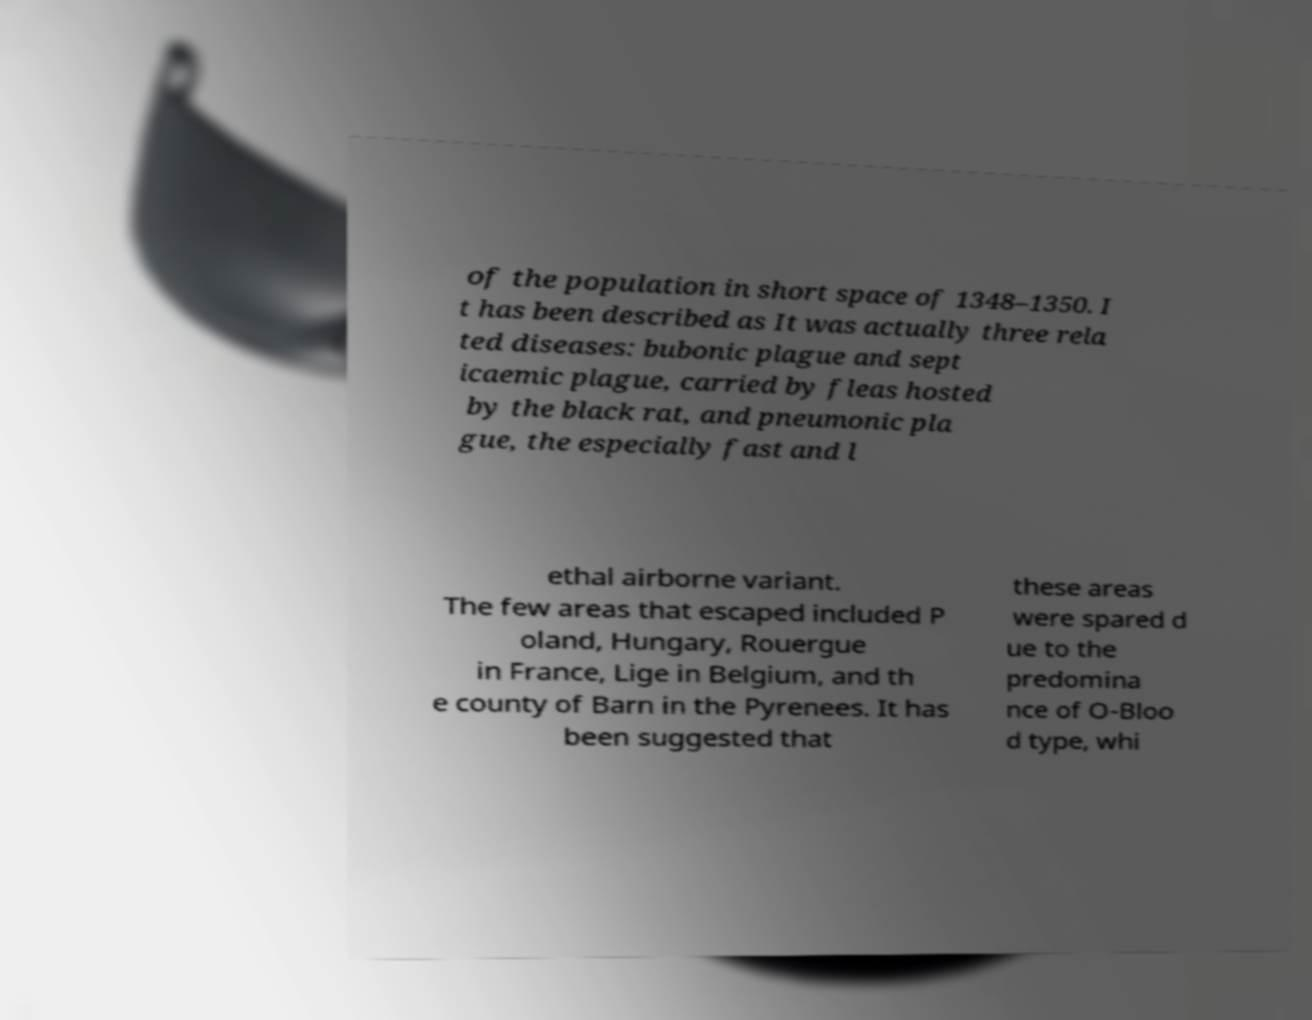Could you assist in decoding the text presented in this image and type it out clearly? of the population in short space of 1348–1350. I t has been described as It was actually three rela ted diseases: bubonic plague and sept icaemic plague, carried by fleas hosted by the black rat, and pneumonic pla gue, the especially fast and l ethal airborne variant. The few areas that escaped included P oland, Hungary, Rouergue in France, Lige in Belgium, and th e county of Barn in the Pyrenees. It has been suggested that these areas were spared d ue to the predomina nce of O-Bloo d type, whi 